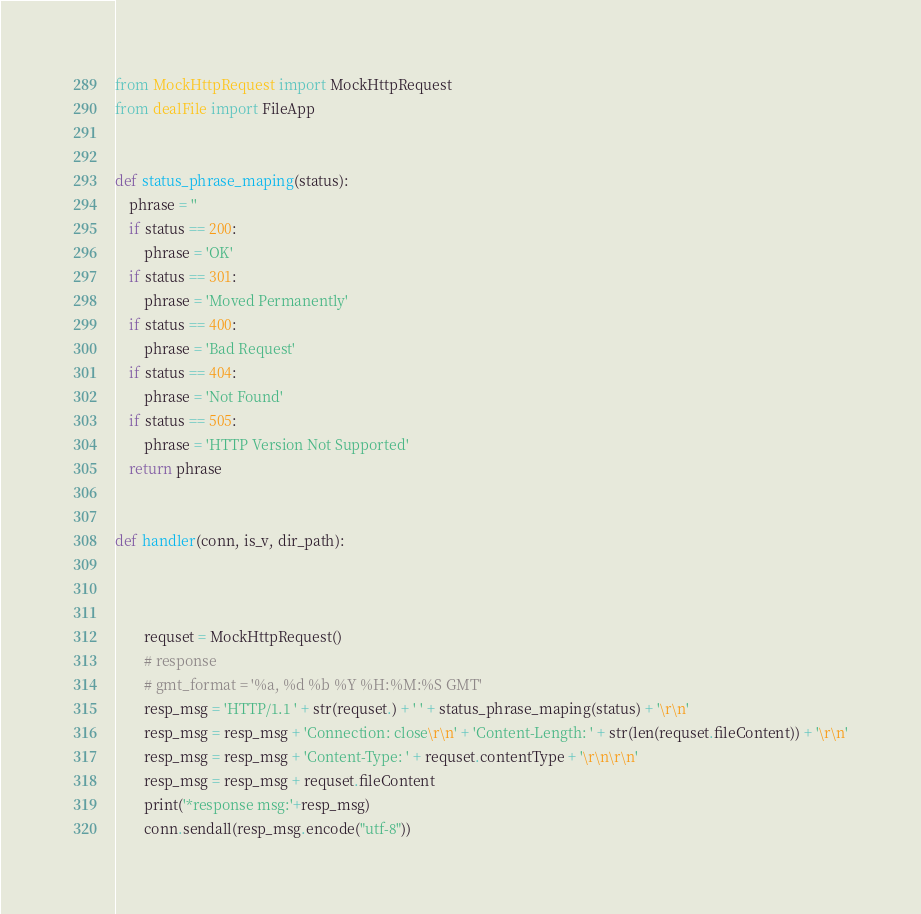<code> <loc_0><loc_0><loc_500><loc_500><_Python_>
from MockHttpRequest import MockHttpRequest
from dealFile import FileApp


def status_phrase_maping(status):
    phrase = ''
    if status == 200:
        phrase = 'OK'
    if status == 301:
        phrase = 'Moved Permanently'
    if status == 400:
        phrase = 'Bad Request'
    if status == 404:
        phrase = 'Not Found'
    if status == 505:
        phrase = 'HTTP Version Not Supported'
    return phrase


def handler(conn, is_v, dir_path):



        requset = MockHttpRequest()
        # response
        # gmt_format = '%a, %d %b %Y %H:%M:%S GMT'
        resp_msg = 'HTTP/1.1 ' + str(requset.) + ' ' + status_phrase_maping(status) + '\r\n'
        resp_msg = resp_msg + 'Connection: close\r\n' + 'Content-Length: ' + str(len(requset.fileContent)) + '\r\n'
        resp_msg = resp_msg + 'Content-Type: ' + requset.contentType + '\r\n\r\n'
        resp_msg = resp_msg + requset.fileContent
        print('*response msg:'+resp_msg)
        conn.sendall(resp_msg.encode("utf-8"))


</code> 